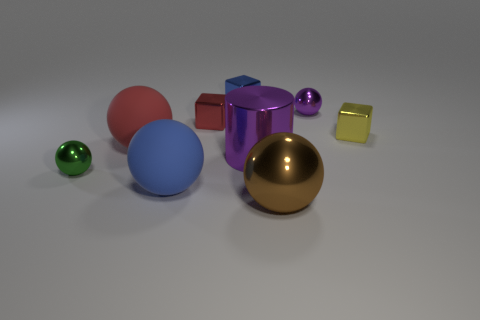Subtract 2 balls. How many balls are left? 3 Subtract all brown balls. How many balls are left? 4 Subtract all blue balls. How many balls are left? 4 Subtract all gray spheres. Subtract all blue blocks. How many spheres are left? 5 Add 1 tiny blue metallic balls. How many objects exist? 10 Subtract all spheres. How many objects are left? 4 Add 5 tiny shiny objects. How many tiny shiny objects exist? 10 Subtract 0 purple blocks. How many objects are left? 9 Subtract all purple shiny objects. Subtract all big blue matte spheres. How many objects are left? 6 Add 5 yellow metallic cubes. How many yellow metallic cubes are left? 6 